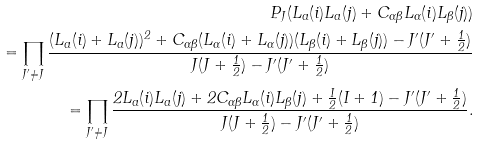<formula> <loc_0><loc_0><loc_500><loc_500>P _ { J } ( L _ { a } ( i ) L _ { a } ( j ) + C _ { \alpha \beta } L _ { \alpha } ( i ) L _ { \beta } ( j ) ) \\ = \prod _ { J ^ { \prime } \neq J } \frac { ( L _ { a } ( i ) + L _ { a } ( j ) ) ^ { 2 } + C _ { \alpha \beta } ( L _ { \alpha } ( i ) + L _ { \alpha } ( j ) ) ( L _ { \beta } ( i ) + L _ { \beta } ( j ) ) - J ^ { \prime } ( J ^ { \prime } + \frac { 1 } { 2 } ) } { J ( J + \frac { 1 } { 2 } ) - J ^ { \prime } ( J ^ { \prime } + \frac { 1 } { 2 } ) } \\ = \prod _ { J ^ { \prime } \neq J } \frac { 2 L _ { a } ( i ) L _ { a } ( j ) + 2 C _ { \alpha \beta } L _ { \alpha } ( i ) L _ { \beta } ( j ) + \frac { I } { 2 } ( I + 1 ) - J ^ { \prime } ( J ^ { \prime } + \frac { 1 } { 2 } ) } { J ( J + \frac { 1 } { 2 } ) - J ^ { \prime } ( J ^ { \prime } + \frac { 1 } { 2 } ) } .</formula> 